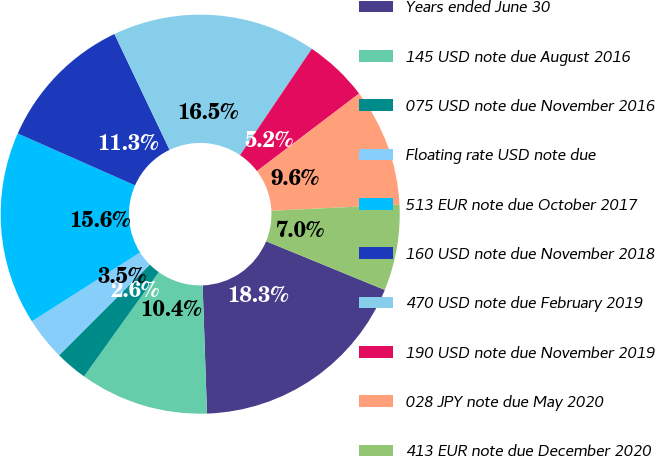Convert chart. <chart><loc_0><loc_0><loc_500><loc_500><pie_chart><fcel>Years ended June 30<fcel>145 USD note due August 2016<fcel>075 USD note due November 2016<fcel>Floating rate USD note due<fcel>513 EUR note due October 2017<fcel>160 USD note due November 2018<fcel>470 USD note due February 2019<fcel>190 USD note due November 2019<fcel>028 JPY note due May 2020<fcel>413 EUR note due December 2020<nl><fcel>18.26%<fcel>10.43%<fcel>2.61%<fcel>3.48%<fcel>15.65%<fcel>11.3%<fcel>16.52%<fcel>5.22%<fcel>9.57%<fcel>6.96%<nl></chart> 